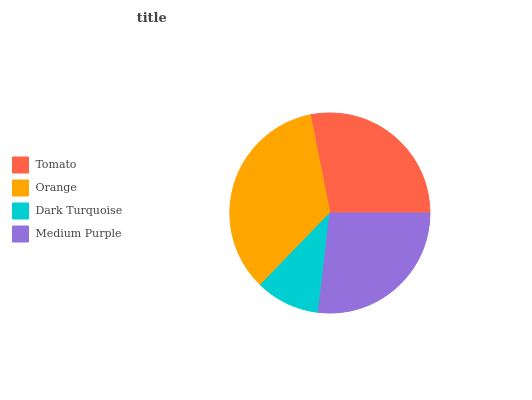Is Dark Turquoise the minimum?
Answer yes or no. Yes. Is Orange the maximum?
Answer yes or no. Yes. Is Orange the minimum?
Answer yes or no. No. Is Dark Turquoise the maximum?
Answer yes or no. No. Is Orange greater than Dark Turquoise?
Answer yes or no. Yes. Is Dark Turquoise less than Orange?
Answer yes or no. Yes. Is Dark Turquoise greater than Orange?
Answer yes or no. No. Is Orange less than Dark Turquoise?
Answer yes or no. No. Is Tomato the high median?
Answer yes or no. Yes. Is Medium Purple the low median?
Answer yes or no. Yes. Is Dark Turquoise the high median?
Answer yes or no. No. Is Tomato the low median?
Answer yes or no. No. 